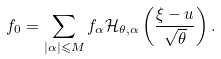<formula> <loc_0><loc_0><loc_500><loc_500>f _ { 0 } = \sum _ { | \alpha | \leqslant M } f _ { \alpha } \mathcal { H } _ { \theta , \alpha } \left ( \frac { \xi - u } { \sqrt { \theta } } \right ) .</formula> 